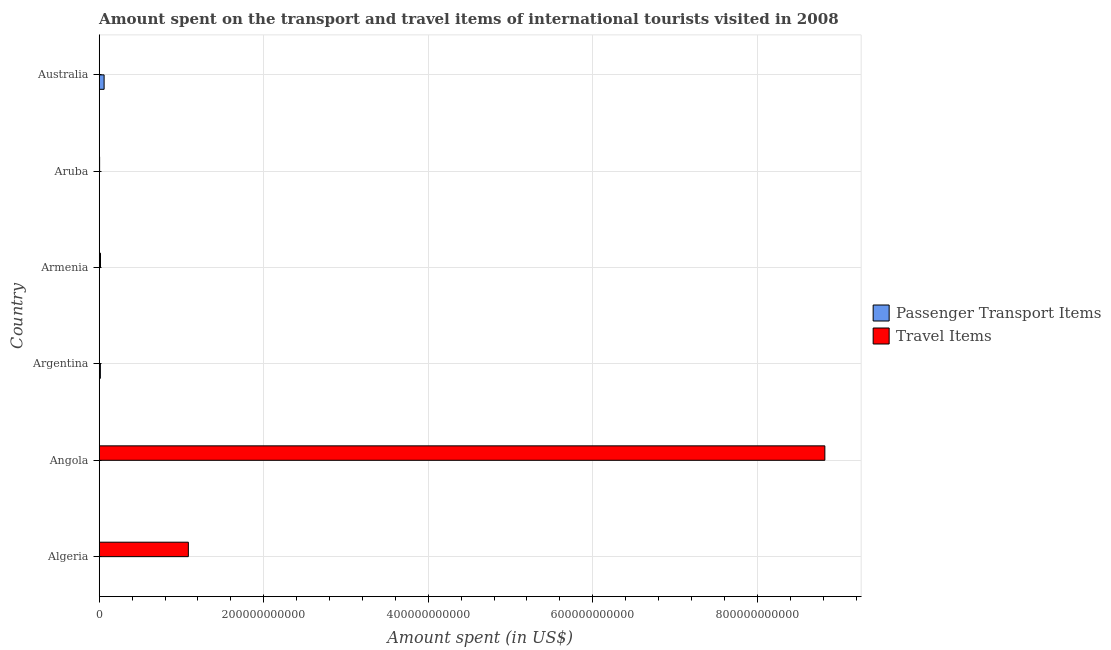Are the number of bars on each tick of the Y-axis equal?
Your response must be concise. Yes. How many bars are there on the 4th tick from the top?
Make the answer very short. 2. How many bars are there on the 1st tick from the bottom?
Offer a terse response. 2. What is the label of the 1st group of bars from the top?
Provide a succinct answer. Australia. What is the amount spent in travel items in Aruba?
Ensure brevity in your answer.  4.68e+08. Across all countries, what is the maximum amount spent in travel items?
Provide a short and direct response. 8.82e+11. Across all countries, what is the minimum amount spent in travel items?
Provide a succinct answer. 5.50e+07. In which country was the amount spent on passenger transport items maximum?
Your answer should be compact. Australia. In which country was the amount spent on passenger transport items minimum?
Offer a terse response. Aruba. What is the total amount spent in travel items in the graph?
Your response must be concise. 9.93e+11. What is the difference between the amount spent on passenger transport items in Algeria and that in Armenia?
Keep it short and to the point. 8.60e+07. What is the difference between the amount spent on passenger transport items in Argentina and the amount spent in travel items in Armenia?
Provide a short and direct response. -1.54e+08. What is the average amount spent on passenger transport items per country?
Provide a succinct answer. 1.29e+09. What is the difference between the amount spent on passenger transport items and amount spent in travel items in Algeria?
Your answer should be very brief. -1.08e+11. In how many countries, is the amount spent in travel items greater than 200000000000 US$?
Keep it short and to the point. 1. What is the ratio of the amount spent on passenger transport items in Argentina to that in Australia?
Your response must be concise. 0.24. Is the difference between the amount spent in travel items in Argentina and Australia greater than the difference between the amount spent on passenger transport items in Argentina and Australia?
Ensure brevity in your answer.  Yes. What is the difference between the highest and the second highest amount spent in travel items?
Make the answer very short. 7.74e+11. What is the difference between the highest and the lowest amount spent in travel items?
Provide a short and direct response. 8.82e+11. What does the 2nd bar from the top in Angola represents?
Make the answer very short. Passenger Transport Items. What does the 2nd bar from the bottom in Armenia represents?
Your answer should be very brief. Travel Items. How many bars are there?
Your answer should be very brief. 12. Are all the bars in the graph horizontal?
Your answer should be very brief. Yes. How many countries are there in the graph?
Your answer should be very brief. 6. What is the difference between two consecutive major ticks on the X-axis?
Offer a terse response. 2.00e+11. Does the graph contain grids?
Keep it short and to the point. Yes. How many legend labels are there?
Your response must be concise. 2. What is the title of the graph?
Offer a terse response. Amount spent on the transport and travel items of international tourists visited in 2008. Does "Research and Development" appear as one of the legend labels in the graph?
Give a very brief answer. No. What is the label or title of the X-axis?
Keep it short and to the point. Amount spent (in US$). What is the Amount spent (in US$) of Passenger Transport Items in Algeria?
Offer a very short reply. 1.45e+08. What is the Amount spent (in US$) in Travel Items in Algeria?
Your response must be concise. 1.08e+11. What is the Amount spent (in US$) in Passenger Transport Items in Angola?
Your answer should be very brief. 1.93e+08. What is the Amount spent (in US$) in Travel Items in Angola?
Give a very brief answer. 8.82e+11. What is the Amount spent (in US$) of Passenger Transport Items in Argentina?
Your answer should be very brief. 1.40e+09. What is the Amount spent (in US$) of Travel Items in Argentina?
Give a very brief answer. 5.50e+07. What is the Amount spent (in US$) in Passenger Transport Items in Armenia?
Your response must be concise. 5.90e+07. What is the Amount spent (in US$) in Travel Items in Armenia?
Give a very brief answer. 1.56e+09. What is the Amount spent (in US$) in Passenger Transport Items in Aruba?
Make the answer very short. 2.20e+07. What is the Amount spent (in US$) of Travel Items in Aruba?
Ensure brevity in your answer.  4.68e+08. What is the Amount spent (in US$) in Passenger Transport Items in Australia?
Make the answer very short. 5.94e+09. What is the Amount spent (in US$) in Travel Items in Australia?
Your response must be concise. 2.54e+08. Across all countries, what is the maximum Amount spent (in US$) in Passenger Transport Items?
Offer a terse response. 5.94e+09. Across all countries, what is the maximum Amount spent (in US$) of Travel Items?
Offer a very short reply. 8.82e+11. Across all countries, what is the minimum Amount spent (in US$) of Passenger Transport Items?
Your answer should be compact. 2.20e+07. Across all countries, what is the minimum Amount spent (in US$) in Travel Items?
Make the answer very short. 5.50e+07. What is the total Amount spent (in US$) in Passenger Transport Items in the graph?
Provide a short and direct response. 7.76e+09. What is the total Amount spent (in US$) of Travel Items in the graph?
Offer a terse response. 9.93e+11. What is the difference between the Amount spent (in US$) in Passenger Transport Items in Algeria and that in Angola?
Your response must be concise. -4.80e+07. What is the difference between the Amount spent (in US$) of Travel Items in Algeria and that in Angola?
Give a very brief answer. -7.74e+11. What is the difference between the Amount spent (in US$) in Passenger Transport Items in Algeria and that in Argentina?
Your response must be concise. -1.26e+09. What is the difference between the Amount spent (in US$) in Travel Items in Algeria and that in Argentina?
Provide a short and direct response. 1.08e+11. What is the difference between the Amount spent (in US$) of Passenger Transport Items in Algeria and that in Armenia?
Provide a short and direct response. 8.60e+07. What is the difference between the Amount spent (in US$) in Travel Items in Algeria and that in Armenia?
Offer a very short reply. 1.07e+11. What is the difference between the Amount spent (in US$) of Passenger Transport Items in Algeria and that in Aruba?
Keep it short and to the point. 1.23e+08. What is the difference between the Amount spent (in US$) of Travel Items in Algeria and that in Aruba?
Your response must be concise. 1.08e+11. What is the difference between the Amount spent (in US$) in Passenger Transport Items in Algeria and that in Australia?
Your answer should be very brief. -5.80e+09. What is the difference between the Amount spent (in US$) in Travel Items in Algeria and that in Australia?
Your answer should be very brief. 1.08e+11. What is the difference between the Amount spent (in US$) in Passenger Transport Items in Angola and that in Argentina?
Give a very brief answer. -1.21e+09. What is the difference between the Amount spent (in US$) in Travel Items in Angola and that in Argentina?
Make the answer very short. 8.82e+11. What is the difference between the Amount spent (in US$) in Passenger Transport Items in Angola and that in Armenia?
Provide a short and direct response. 1.34e+08. What is the difference between the Amount spent (in US$) in Travel Items in Angola and that in Armenia?
Your response must be concise. 8.81e+11. What is the difference between the Amount spent (in US$) in Passenger Transport Items in Angola and that in Aruba?
Your answer should be compact. 1.71e+08. What is the difference between the Amount spent (in US$) of Travel Items in Angola and that in Aruba?
Provide a succinct answer. 8.82e+11. What is the difference between the Amount spent (in US$) of Passenger Transport Items in Angola and that in Australia?
Make the answer very short. -5.75e+09. What is the difference between the Amount spent (in US$) in Travel Items in Angola and that in Australia?
Provide a short and direct response. 8.82e+11. What is the difference between the Amount spent (in US$) of Passenger Transport Items in Argentina and that in Armenia?
Provide a short and direct response. 1.34e+09. What is the difference between the Amount spent (in US$) in Travel Items in Argentina and that in Armenia?
Offer a very short reply. -1.50e+09. What is the difference between the Amount spent (in US$) in Passenger Transport Items in Argentina and that in Aruba?
Make the answer very short. 1.38e+09. What is the difference between the Amount spent (in US$) of Travel Items in Argentina and that in Aruba?
Your answer should be compact. -4.13e+08. What is the difference between the Amount spent (in US$) in Passenger Transport Items in Argentina and that in Australia?
Give a very brief answer. -4.54e+09. What is the difference between the Amount spent (in US$) of Travel Items in Argentina and that in Australia?
Give a very brief answer. -1.99e+08. What is the difference between the Amount spent (in US$) in Passenger Transport Items in Armenia and that in Aruba?
Your response must be concise. 3.70e+07. What is the difference between the Amount spent (in US$) of Travel Items in Armenia and that in Aruba?
Provide a succinct answer. 1.09e+09. What is the difference between the Amount spent (in US$) in Passenger Transport Items in Armenia and that in Australia?
Make the answer very short. -5.88e+09. What is the difference between the Amount spent (in US$) of Travel Items in Armenia and that in Australia?
Offer a very short reply. 1.30e+09. What is the difference between the Amount spent (in US$) in Passenger Transport Items in Aruba and that in Australia?
Keep it short and to the point. -5.92e+09. What is the difference between the Amount spent (in US$) in Travel Items in Aruba and that in Australia?
Offer a terse response. 2.14e+08. What is the difference between the Amount spent (in US$) of Passenger Transport Items in Algeria and the Amount spent (in US$) of Travel Items in Angola?
Ensure brevity in your answer.  -8.82e+11. What is the difference between the Amount spent (in US$) of Passenger Transport Items in Algeria and the Amount spent (in US$) of Travel Items in Argentina?
Offer a very short reply. 9.00e+07. What is the difference between the Amount spent (in US$) of Passenger Transport Items in Algeria and the Amount spent (in US$) of Travel Items in Armenia?
Offer a very short reply. -1.41e+09. What is the difference between the Amount spent (in US$) in Passenger Transport Items in Algeria and the Amount spent (in US$) in Travel Items in Aruba?
Offer a very short reply. -3.23e+08. What is the difference between the Amount spent (in US$) in Passenger Transport Items in Algeria and the Amount spent (in US$) in Travel Items in Australia?
Keep it short and to the point. -1.09e+08. What is the difference between the Amount spent (in US$) in Passenger Transport Items in Angola and the Amount spent (in US$) in Travel Items in Argentina?
Make the answer very short. 1.38e+08. What is the difference between the Amount spent (in US$) of Passenger Transport Items in Angola and the Amount spent (in US$) of Travel Items in Armenia?
Keep it short and to the point. -1.36e+09. What is the difference between the Amount spent (in US$) in Passenger Transport Items in Angola and the Amount spent (in US$) in Travel Items in Aruba?
Your answer should be very brief. -2.75e+08. What is the difference between the Amount spent (in US$) in Passenger Transport Items in Angola and the Amount spent (in US$) in Travel Items in Australia?
Ensure brevity in your answer.  -6.10e+07. What is the difference between the Amount spent (in US$) in Passenger Transport Items in Argentina and the Amount spent (in US$) in Travel Items in Armenia?
Your answer should be compact. -1.54e+08. What is the difference between the Amount spent (in US$) in Passenger Transport Items in Argentina and the Amount spent (in US$) in Travel Items in Aruba?
Your answer should be compact. 9.33e+08. What is the difference between the Amount spent (in US$) of Passenger Transport Items in Argentina and the Amount spent (in US$) of Travel Items in Australia?
Provide a succinct answer. 1.15e+09. What is the difference between the Amount spent (in US$) of Passenger Transport Items in Armenia and the Amount spent (in US$) of Travel Items in Aruba?
Your answer should be very brief. -4.09e+08. What is the difference between the Amount spent (in US$) in Passenger Transport Items in Armenia and the Amount spent (in US$) in Travel Items in Australia?
Your answer should be compact. -1.95e+08. What is the difference between the Amount spent (in US$) in Passenger Transport Items in Aruba and the Amount spent (in US$) in Travel Items in Australia?
Offer a terse response. -2.32e+08. What is the average Amount spent (in US$) in Passenger Transport Items per country?
Make the answer very short. 1.29e+09. What is the average Amount spent (in US$) in Travel Items per country?
Your answer should be compact. 1.65e+11. What is the difference between the Amount spent (in US$) in Passenger Transport Items and Amount spent (in US$) in Travel Items in Algeria?
Your response must be concise. -1.08e+11. What is the difference between the Amount spent (in US$) of Passenger Transport Items and Amount spent (in US$) of Travel Items in Angola?
Your response must be concise. -8.82e+11. What is the difference between the Amount spent (in US$) in Passenger Transport Items and Amount spent (in US$) in Travel Items in Argentina?
Keep it short and to the point. 1.35e+09. What is the difference between the Amount spent (in US$) of Passenger Transport Items and Amount spent (in US$) of Travel Items in Armenia?
Offer a terse response. -1.50e+09. What is the difference between the Amount spent (in US$) of Passenger Transport Items and Amount spent (in US$) of Travel Items in Aruba?
Your answer should be very brief. -4.46e+08. What is the difference between the Amount spent (in US$) of Passenger Transport Items and Amount spent (in US$) of Travel Items in Australia?
Your answer should be compact. 5.69e+09. What is the ratio of the Amount spent (in US$) of Passenger Transport Items in Algeria to that in Angola?
Give a very brief answer. 0.75. What is the ratio of the Amount spent (in US$) of Travel Items in Algeria to that in Angola?
Make the answer very short. 0.12. What is the ratio of the Amount spent (in US$) in Passenger Transport Items in Algeria to that in Argentina?
Your answer should be compact. 0.1. What is the ratio of the Amount spent (in US$) of Travel Items in Algeria to that in Argentina?
Give a very brief answer. 1970.16. What is the ratio of the Amount spent (in US$) of Passenger Transport Items in Algeria to that in Armenia?
Offer a terse response. 2.46. What is the ratio of the Amount spent (in US$) in Travel Items in Algeria to that in Armenia?
Provide a succinct answer. 69.68. What is the ratio of the Amount spent (in US$) in Passenger Transport Items in Algeria to that in Aruba?
Offer a very short reply. 6.59. What is the ratio of the Amount spent (in US$) in Travel Items in Algeria to that in Aruba?
Keep it short and to the point. 231.54. What is the ratio of the Amount spent (in US$) in Passenger Transport Items in Algeria to that in Australia?
Provide a succinct answer. 0.02. What is the ratio of the Amount spent (in US$) of Travel Items in Algeria to that in Australia?
Provide a short and direct response. 426.61. What is the ratio of the Amount spent (in US$) of Passenger Transport Items in Angola to that in Argentina?
Provide a short and direct response. 0.14. What is the ratio of the Amount spent (in US$) in Travel Items in Angola to that in Argentina?
Offer a very short reply. 1.60e+04. What is the ratio of the Amount spent (in US$) of Passenger Transport Items in Angola to that in Armenia?
Ensure brevity in your answer.  3.27. What is the ratio of the Amount spent (in US$) in Travel Items in Angola to that in Armenia?
Your answer should be very brief. 567.3. What is the ratio of the Amount spent (in US$) of Passenger Transport Items in Angola to that in Aruba?
Your answer should be compact. 8.77. What is the ratio of the Amount spent (in US$) of Travel Items in Angola to that in Aruba?
Offer a very short reply. 1884.96. What is the ratio of the Amount spent (in US$) of Passenger Transport Items in Angola to that in Australia?
Ensure brevity in your answer.  0.03. What is the ratio of the Amount spent (in US$) in Travel Items in Angola to that in Australia?
Offer a very short reply. 3473.07. What is the ratio of the Amount spent (in US$) in Passenger Transport Items in Argentina to that in Armenia?
Your answer should be very brief. 23.75. What is the ratio of the Amount spent (in US$) in Travel Items in Argentina to that in Armenia?
Provide a short and direct response. 0.04. What is the ratio of the Amount spent (in US$) of Passenger Transport Items in Argentina to that in Aruba?
Make the answer very short. 63.68. What is the ratio of the Amount spent (in US$) of Travel Items in Argentina to that in Aruba?
Make the answer very short. 0.12. What is the ratio of the Amount spent (in US$) in Passenger Transport Items in Argentina to that in Australia?
Provide a short and direct response. 0.24. What is the ratio of the Amount spent (in US$) in Travel Items in Argentina to that in Australia?
Ensure brevity in your answer.  0.22. What is the ratio of the Amount spent (in US$) of Passenger Transport Items in Armenia to that in Aruba?
Make the answer very short. 2.68. What is the ratio of the Amount spent (in US$) in Travel Items in Armenia to that in Aruba?
Provide a short and direct response. 3.32. What is the ratio of the Amount spent (in US$) of Passenger Transport Items in Armenia to that in Australia?
Offer a very short reply. 0.01. What is the ratio of the Amount spent (in US$) of Travel Items in Armenia to that in Australia?
Your answer should be very brief. 6.12. What is the ratio of the Amount spent (in US$) in Passenger Transport Items in Aruba to that in Australia?
Offer a very short reply. 0. What is the ratio of the Amount spent (in US$) in Travel Items in Aruba to that in Australia?
Make the answer very short. 1.84. What is the difference between the highest and the second highest Amount spent (in US$) of Passenger Transport Items?
Your response must be concise. 4.54e+09. What is the difference between the highest and the second highest Amount spent (in US$) in Travel Items?
Ensure brevity in your answer.  7.74e+11. What is the difference between the highest and the lowest Amount spent (in US$) of Passenger Transport Items?
Make the answer very short. 5.92e+09. What is the difference between the highest and the lowest Amount spent (in US$) in Travel Items?
Give a very brief answer. 8.82e+11. 